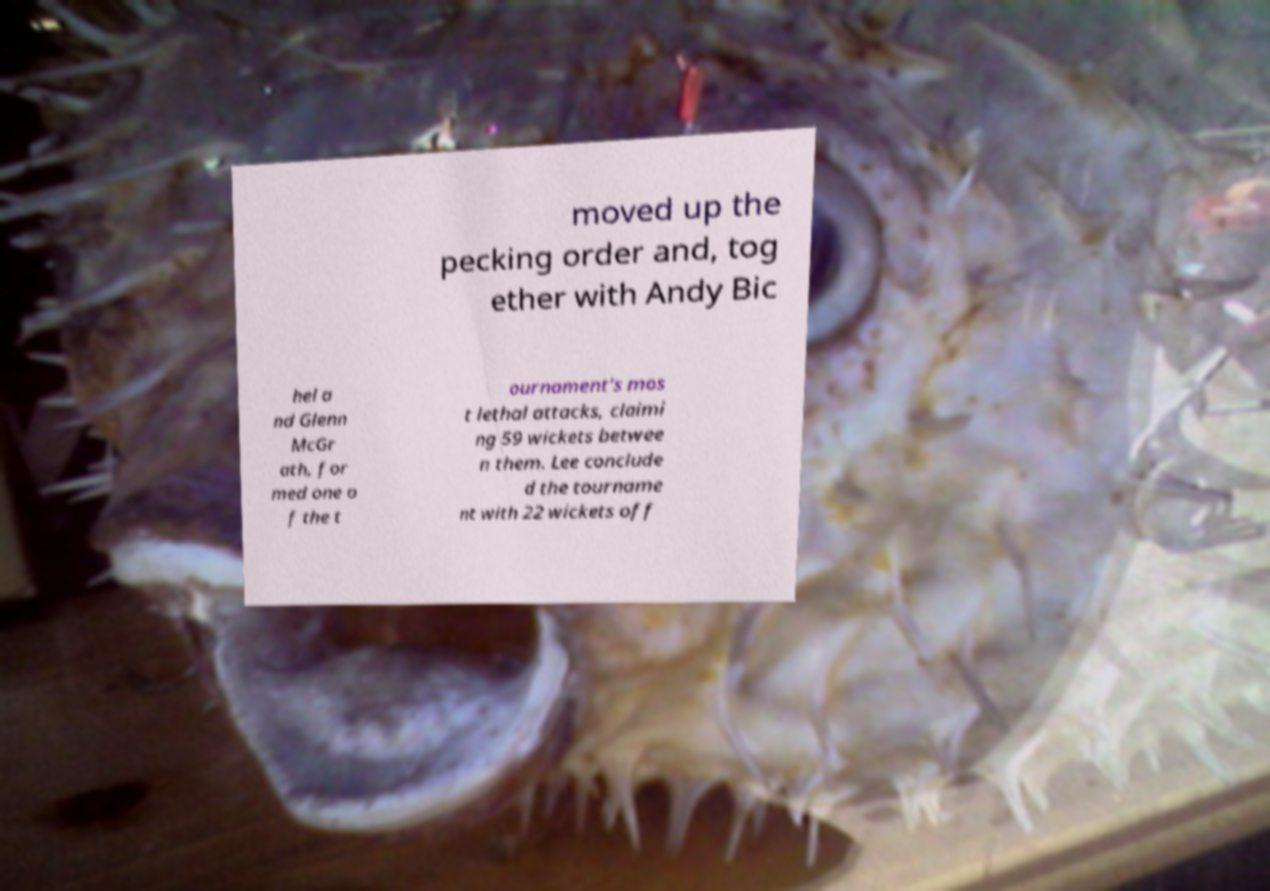What messages or text are displayed in this image? I need them in a readable, typed format. moved up the pecking order and, tog ether with Andy Bic hel a nd Glenn McGr ath, for med one o f the t ournament's mos t lethal attacks, claimi ng 59 wickets betwee n them. Lee conclude d the tourname nt with 22 wickets off 